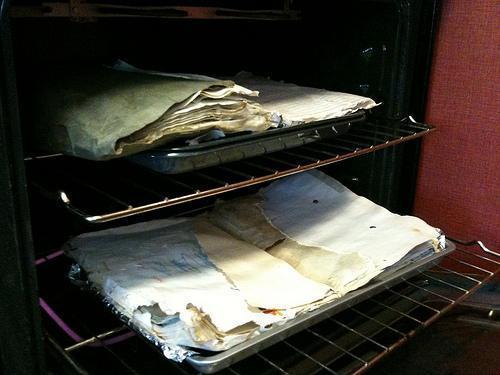How many grates are there?
Give a very brief answer. 2. How many silver trays are there?
Give a very brief answer. 3. 